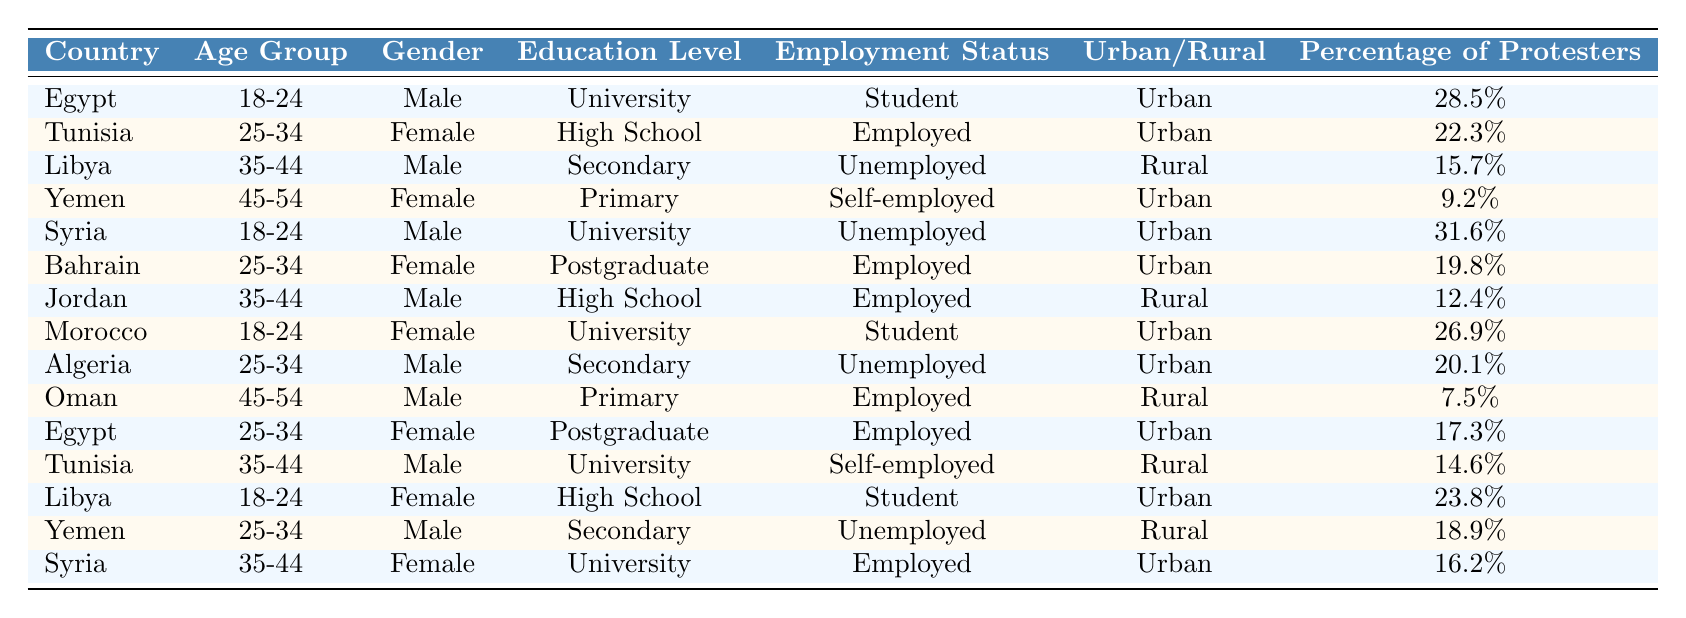What percentage of protesters in Syria are in the age group 18-24? The table shows that 31.6% of protesters in Syria belong to the 18-24 age group.
Answer: 31.6% Which gender has a higher representation among protesters in the age group 25-34 in Tunisia? The table lists that the female protesters represent 22.3% in the 25-34 age group, while the male protesters number is not specified in that age group for Tunisia, but a male protester in 35-44 age group is indicated. Therefore, it is unclear, but the given data for 25-34 is only for females.
Answer: Female What is the average percentage of protesters in the age group 35-44 across all countries listed? The percentages for the 35-44 age group are 15.7 (Libya), 12.4 (Jordan), and 16.2 (Syria). Adding these gives 15.7 + 12.4 + 16.2 = 44.3. Then dividing by 3 gives an average of 14.77.
Answer: 14.77% In which country is the lowest percentage of female protesters found? The data reveals that Yemen has the lowest percentage of female protesters at 9.2%.
Answer: Yemen What is the difference in the percentage of male and female protesters in the age group 18-24 in Egypt? For Egypt, male protesters in the 18-24 age group comprise 28.5%, while female protesters in the same age group are not specified here. Since only one percentage is provided for males, the difference cannot be calculated and female data is absent.
Answer: Not calculable Are the majority of protesters in urban or rural settings according to the data? By counting the urban settings: Egypt, Tunisia, Syria, Bahrain, Morocco, and Algeria, we find 8 urban records. In rural settings we have Libya, Yemen, and Jordan. Therefore, urban settings have a greater representation than rural.
Answer: Urban settings have a majority What percentage of female protesters in Libya belong to the age group 18-24? The table shows that 23.8% of female protesters in Libya belong to the age group 18-24.
Answer: 23.8% Which country had the highest percentage of male protesters in the age group 45-54? Oman has the highest percentage of male protesters in the 45-54 age group at 7.5%.
Answer: Oman Which age group has the highest percentage of protesters overall across all countries? The highest percentage is 31.6% from the 18-24 age group in Syria.
Answer: 31.6% How many total age groups are represented in the data? The table displays protesters from 5 different age groups: 18-24, 25-34, 35-44, 45-54, and one implicit for those unspecified, totaling 4 distinct age categories.
Answer: 4 age groups 